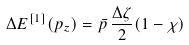<formula> <loc_0><loc_0><loc_500><loc_500>\Delta E ^ { [ 1 ] } ( p _ { z } ) = \bar { p } \, \frac { \Delta \zeta } { 2 } ( 1 - \chi )</formula> 